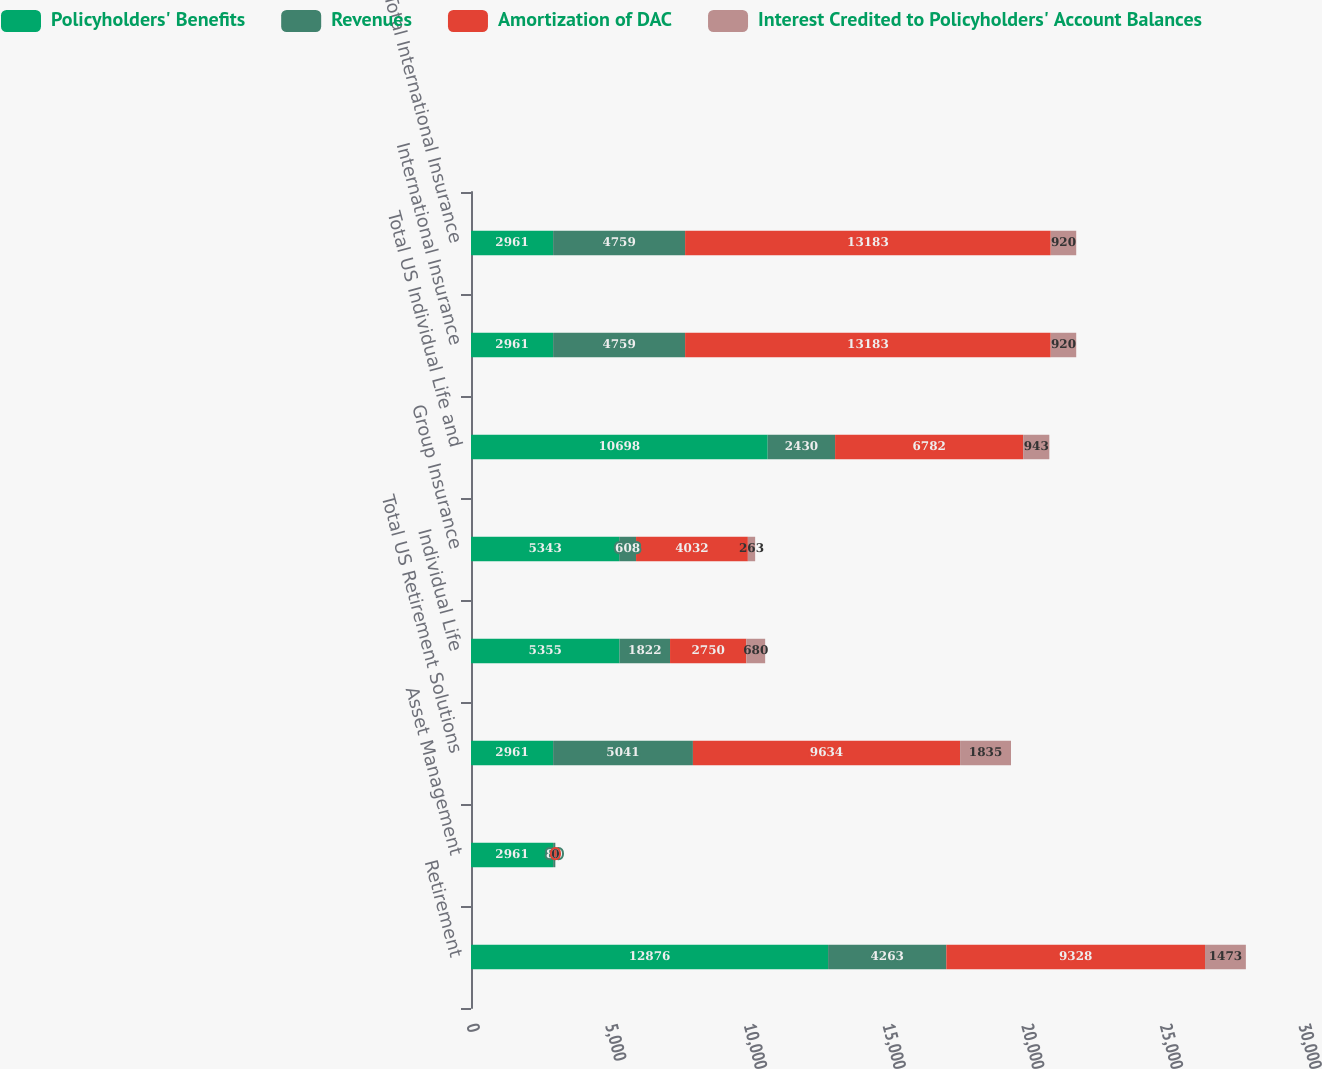Convert chart to OTSL. <chart><loc_0><loc_0><loc_500><loc_500><stacked_bar_chart><ecel><fcel>Retirement<fcel>Asset Management<fcel>Total US Retirement Solutions<fcel>Individual Life<fcel>Group Insurance<fcel>Total US Individual Life and<fcel>International Insurance<fcel>Total International Insurance<nl><fcel>Policyholders' Benefits<fcel>12876<fcel>2961<fcel>2961<fcel>5355<fcel>5343<fcel>10698<fcel>2961<fcel>2961<nl><fcel>Revenues<fcel>4263<fcel>80<fcel>5041<fcel>1822<fcel>608<fcel>2430<fcel>4759<fcel>4759<nl><fcel>Amortization of DAC<fcel>9328<fcel>0<fcel>9634<fcel>2750<fcel>4032<fcel>6782<fcel>13183<fcel>13183<nl><fcel>Interest Credited to Policyholders' Account Balances<fcel>1473<fcel>0<fcel>1835<fcel>680<fcel>263<fcel>943<fcel>920<fcel>920<nl></chart> 